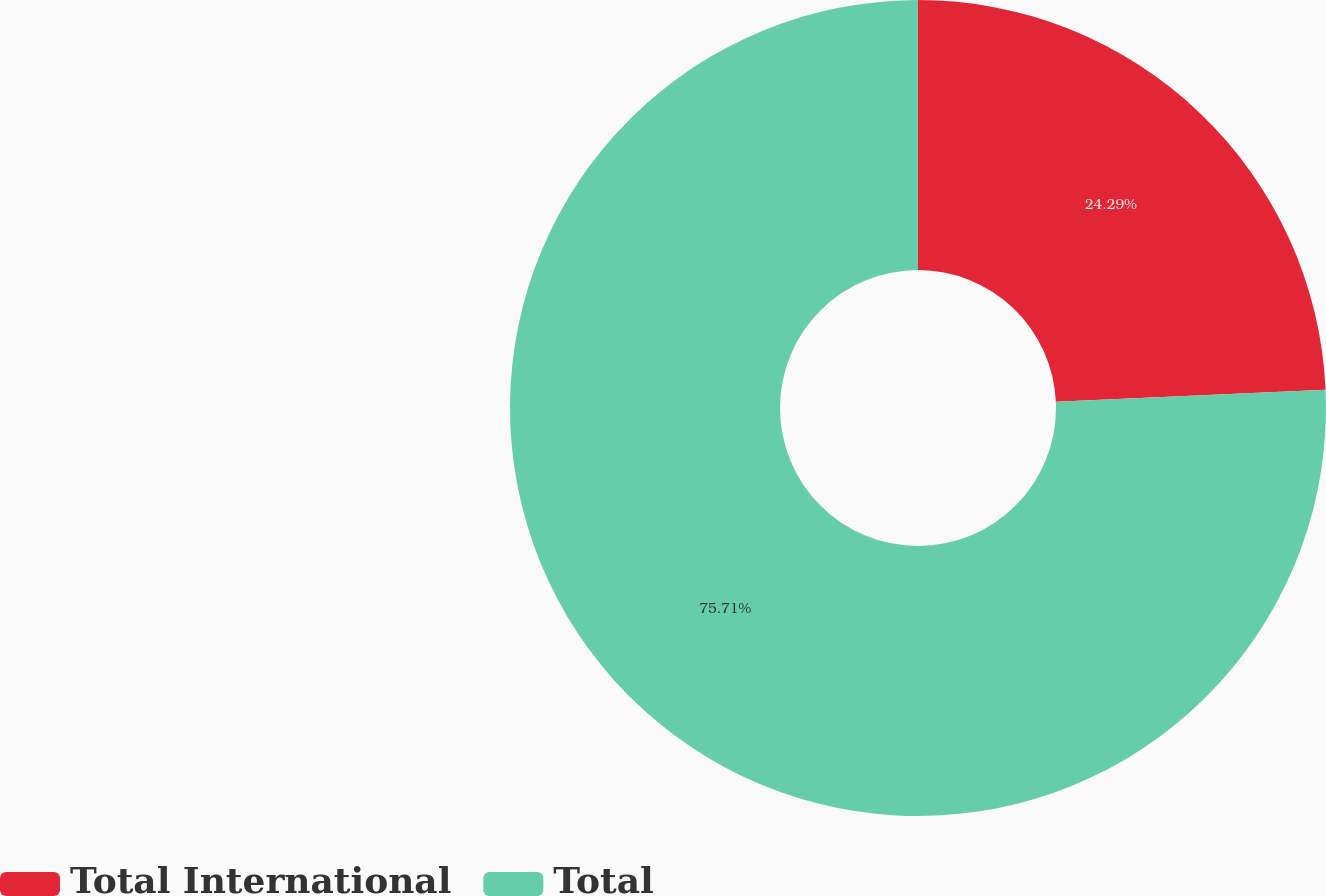Convert chart to OTSL. <chart><loc_0><loc_0><loc_500><loc_500><pie_chart><fcel>Total International<fcel>Total<nl><fcel>24.29%<fcel>75.71%<nl></chart> 